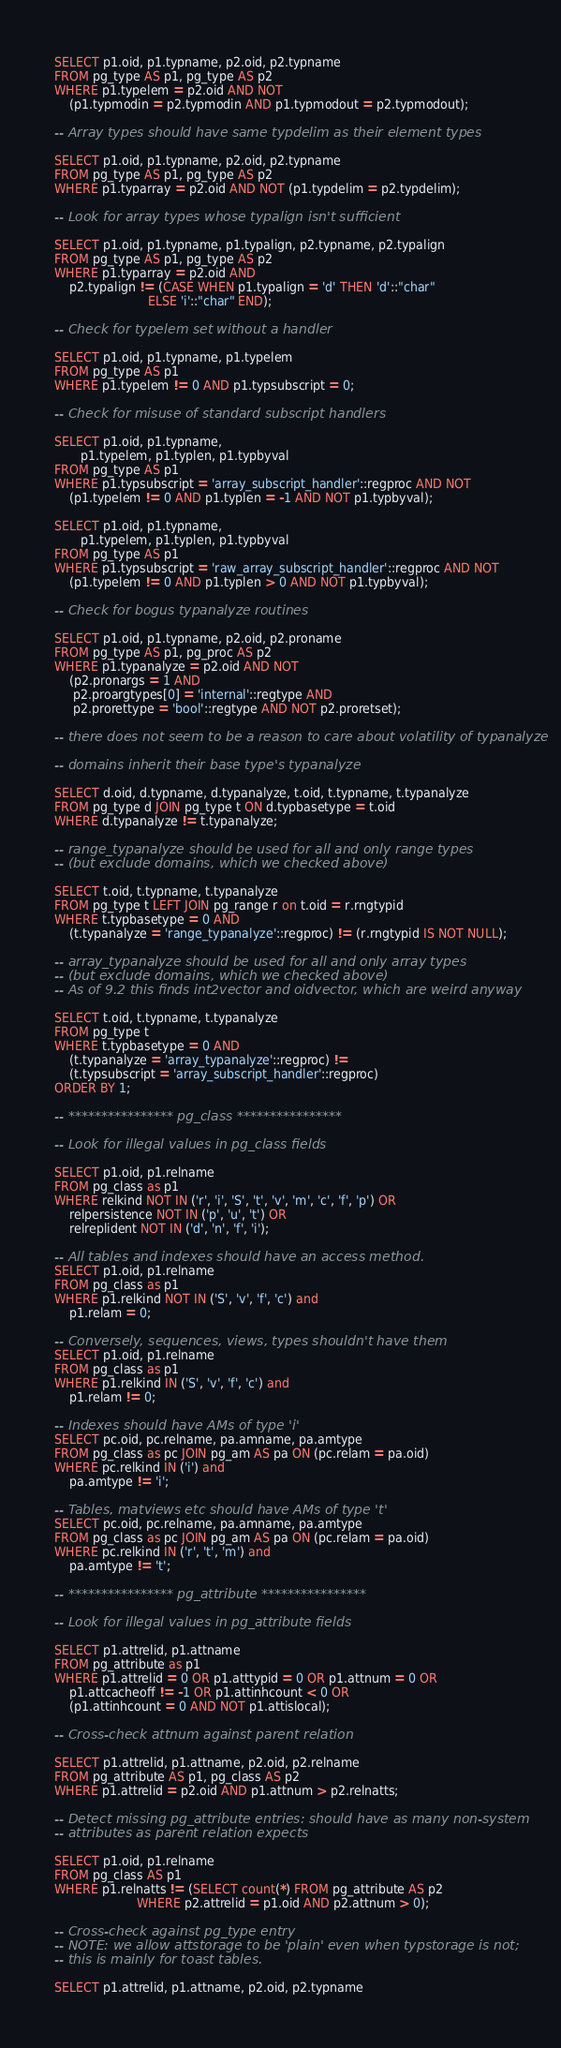Convert code to text. <code><loc_0><loc_0><loc_500><loc_500><_SQL_>SELECT p1.oid, p1.typname, p2.oid, p2.typname
FROM pg_type AS p1, pg_type AS p2
WHERE p1.typelem = p2.oid AND NOT
    (p1.typmodin = p2.typmodin AND p1.typmodout = p2.typmodout);

-- Array types should have same typdelim as their element types

SELECT p1.oid, p1.typname, p2.oid, p2.typname
FROM pg_type AS p1, pg_type AS p2
WHERE p1.typarray = p2.oid AND NOT (p1.typdelim = p2.typdelim);

-- Look for array types whose typalign isn't sufficient

SELECT p1.oid, p1.typname, p1.typalign, p2.typname, p2.typalign
FROM pg_type AS p1, pg_type AS p2
WHERE p1.typarray = p2.oid AND
    p2.typalign != (CASE WHEN p1.typalign = 'd' THEN 'd'::"char"
                         ELSE 'i'::"char" END);

-- Check for typelem set without a handler

SELECT p1.oid, p1.typname, p1.typelem
FROM pg_type AS p1
WHERE p1.typelem != 0 AND p1.typsubscript = 0;

-- Check for misuse of standard subscript handlers

SELECT p1.oid, p1.typname,
       p1.typelem, p1.typlen, p1.typbyval
FROM pg_type AS p1
WHERE p1.typsubscript = 'array_subscript_handler'::regproc AND NOT
    (p1.typelem != 0 AND p1.typlen = -1 AND NOT p1.typbyval);

SELECT p1.oid, p1.typname,
       p1.typelem, p1.typlen, p1.typbyval
FROM pg_type AS p1
WHERE p1.typsubscript = 'raw_array_subscript_handler'::regproc AND NOT
    (p1.typelem != 0 AND p1.typlen > 0 AND NOT p1.typbyval);

-- Check for bogus typanalyze routines

SELECT p1.oid, p1.typname, p2.oid, p2.proname
FROM pg_type AS p1, pg_proc AS p2
WHERE p1.typanalyze = p2.oid AND NOT
    (p2.pronargs = 1 AND
     p2.proargtypes[0] = 'internal'::regtype AND
     p2.prorettype = 'bool'::regtype AND NOT p2.proretset);

-- there does not seem to be a reason to care about volatility of typanalyze

-- domains inherit their base type's typanalyze

SELECT d.oid, d.typname, d.typanalyze, t.oid, t.typname, t.typanalyze
FROM pg_type d JOIN pg_type t ON d.typbasetype = t.oid
WHERE d.typanalyze != t.typanalyze;

-- range_typanalyze should be used for all and only range types
-- (but exclude domains, which we checked above)

SELECT t.oid, t.typname, t.typanalyze
FROM pg_type t LEFT JOIN pg_range r on t.oid = r.rngtypid
WHERE t.typbasetype = 0 AND
    (t.typanalyze = 'range_typanalyze'::regproc) != (r.rngtypid IS NOT NULL);

-- array_typanalyze should be used for all and only array types
-- (but exclude domains, which we checked above)
-- As of 9.2 this finds int2vector and oidvector, which are weird anyway

SELECT t.oid, t.typname, t.typanalyze
FROM pg_type t
WHERE t.typbasetype = 0 AND
    (t.typanalyze = 'array_typanalyze'::regproc) !=
    (t.typsubscript = 'array_subscript_handler'::regproc)
ORDER BY 1;

-- **************** pg_class ****************

-- Look for illegal values in pg_class fields

SELECT p1.oid, p1.relname
FROM pg_class as p1
WHERE relkind NOT IN ('r', 'i', 'S', 't', 'v', 'm', 'c', 'f', 'p') OR
    relpersistence NOT IN ('p', 'u', 't') OR
    relreplident NOT IN ('d', 'n', 'f', 'i');

-- All tables and indexes should have an access method.
SELECT p1.oid, p1.relname
FROM pg_class as p1
WHERE p1.relkind NOT IN ('S', 'v', 'f', 'c') and
    p1.relam = 0;

-- Conversely, sequences, views, types shouldn't have them
SELECT p1.oid, p1.relname
FROM pg_class as p1
WHERE p1.relkind IN ('S', 'v', 'f', 'c') and
    p1.relam != 0;

-- Indexes should have AMs of type 'i'
SELECT pc.oid, pc.relname, pa.amname, pa.amtype
FROM pg_class as pc JOIN pg_am AS pa ON (pc.relam = pa.oid)
WHERE pc.relkind IN ('i') and
    pa.amtype != 'i';

-- Tables, matviews etc should have AMs of type 't'
SELECT pc.oid, pc.relname, pa.amname, pa.amtype
FROM pg_class as pc JOIN pg_am AS pa ON (pc.relam = pa.oid)
WHERE pc.relkind IN ('r', 't', 'm') and
    pa.amtype != 't';

-- **************** pg_attribute ****************

-- Look for illegal values in pg_attribute fields

SELECT p1.attrelid, p1.attname
FROM pg_attribute as p1
WHERE p1.attrelid = 0 OR p1.atttypid = 0 OR p1.attnum = 0 OR
    p1.attcacheoff != -1 OR p1.attinhcount < 0 OR
    (p1.attinhcount = 0 AND NOT p1.attislocal);

-- Cross-check attnum against parent relation

SELECT p1.attrelid, p1.attname, p2.oid, p2.relname
FROM pg_attribute AS p1, pg_class AS p2
WHERE p1.attrelid = p2.oid AND p1.attnum > p2.relnatts;

-- Detect missing pg_attribute entries: should have as many non-system
-- attributes as parent relation expects

SELECT p1.oid, p1.relname
FROM pg_class AS p1
WHERE p1.relnatts != (SELECT count(*) FROM pg_attribute AS p2
                      WHERE p2.attrelid = p1.oid AND p2.attnum > 0);

-- Cross-check against pg_type entry
-- NOTE: we allow attstorage to be 'plain' even when typstorage is not;
-- this is mainly for toast tables.

SELECT p1.attrelid, p1.attname, p2.oid, p2.typname</code> 